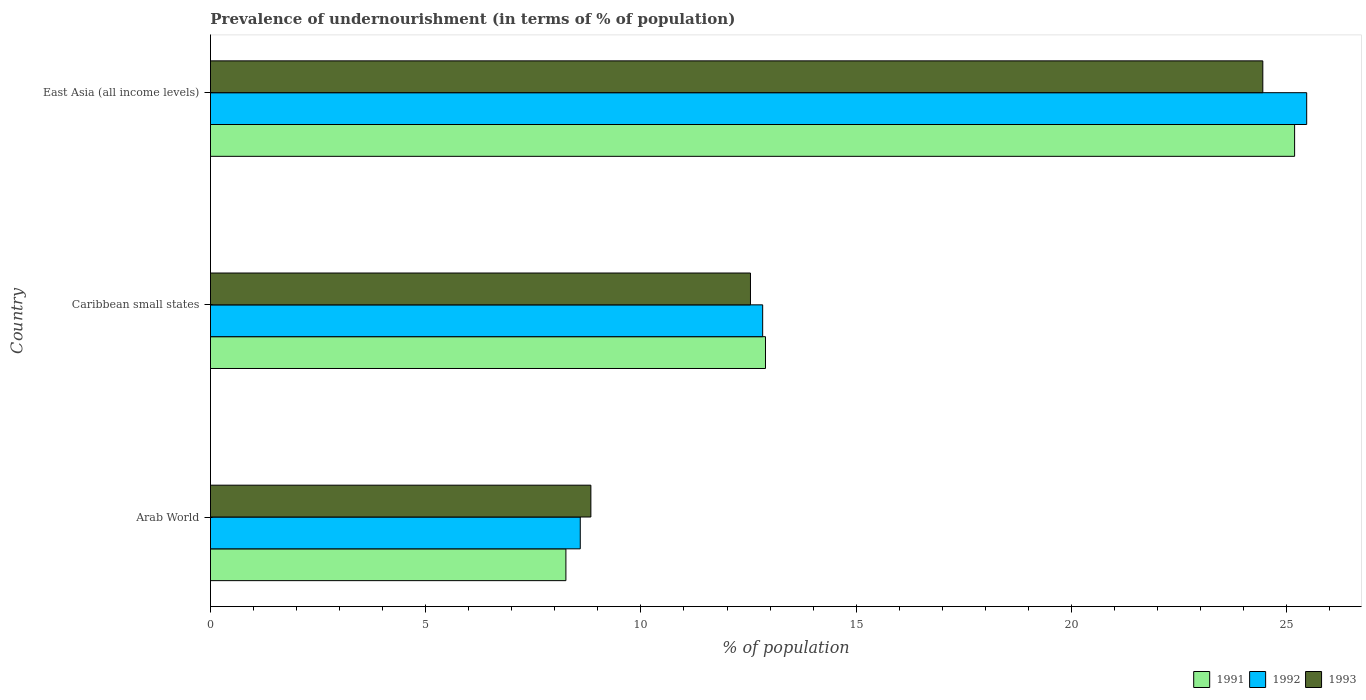How many different coloured bars are there?
Provide a short and direct response. 3. Are the number of bars per tick equal to the number of legend labels?
Make the answer very short. Yes. How many bars are there on the 3rd tick from the top?
Ensure brevity in your answer.  3. What is the label of the 3rd group of bars from the top?
Offer a very short reply. Arab World. In how many cases, is the number of bars for a given country not equal to the number of legend labels?
Make the answer very short. 0. What is the percentage of undernourished population in 1992 in Arab World?
Give a very brief answer. 8.59. Across all countries, what is the maximum percentage of undernourished population in 1993?
Ensure brevity in your answer.  24.45. Across all countries, what is the minimum percentage of undernourished population in 1993?
Offer a terse response. 8.84. In which country was the percentage of undernourished population in 1993 maximum?
Keep it short and to the point. East Asia (all income levels). In which country was the percentage of undernourished population in 1991 minimum?
Offer a very short reply. Arab World. What is the total percentage of undernourished population in 1992 in the graph?
Provide a short and direct response. 46.89. What is the difference between the percentage of undernourished population in 1993 in Caribbean small states and that in East Asia (all income levels)?
Offer a very short reply. -11.9. What is the difference between the percentage of undernourished population in 1992 in Caribbean small states and the percentage of undernourished population in 1993 in East Asia (all income levels)?
Give a very brief answer. -11.62. What is the average percentage of undernourished population in 1991 per country?
Your response must be concise. 15.45. What is the difference between the percentage of undernourished population in 1993 and percentage of undernourished population in 1991 in Arab World?
Make the answer very short. 0.58. What is the ratio of the percentage of undernourished population in 1991 in Caribbean small states to that in East Asia (all income levels)?
Offer a very short reply. 0.51. Is the percentage of undernourished population in 1992 in Arab World less than that in East Asia (all income levels)?
Your response must be concise. Yes. What is the difference between the highest and the second highest percentage of undernourished population in 1993?
Make the answer very short. 11.9. What is the difference between the highest and the lowest percentage of undernourished population in 1991?
Your answer should be compact. 16.93. Is the sum of the percentage of undernourished population in 1992 in Caribbean small states and East Asia (all income levels) greater than the maximum percentage of undernourished population in 1991 across all countries?
Ensure brevity in your answer.  Yes. What does the 1st bar from the top in East Asia (all income levels) represents?
Your answer should be compact. 1993. Is it the case that in every country, the sum of the percentage of undernourished population in 1991 and percentage of undernourished population in 1993 is greater than the percentage of undernourished population in 1992?
Your answer should be compact. Yes. How many bars are there?
Ensure brevity in your answer.  9. Are all the bars in the graph horizontal?
Your answer should be compact. Yes. How many countries are there in the graph?
Your answer should be very brief. 3. Does the graph contain any zero values?
Provide a succinct answer. No. Does the graph contain grids?
Your answer should be very brief. No. Where does the legend appear in the graph?
Keep it short and to the point. Bottom right. How are the legend labels stacked?
Offer a terse response. Horizontal. What is the title of the graph?
Offer a terse response. Prevalence of undernourishment (in terms of % of population). Does "1962" appear as one of the legend labels in the graph?
Give a very brief answer. No. What is the label or title of the X-axis?
Provide a succinct answer. % of population. What is the label or title of the Y-axis?
Your answer should be compact. Country. What is the % of population in 1991 in Arab World?
Give a very brief answer. 8.26. What is the % of population in 1992 in Arab World?
Offer a terse response. 8.59. What is the % of population in 1993 in Arab World?
Offer a terse response. 8.84. What is the % of population of 1991 in Caribbean small states?
Offer a very short reply. 12.89. What is the % of population in 1992 in Caribbean small states?
Keep it short and to the point. 12.83. What is the % of population in 1993 in Caribbean small states?
Ensure brevity in your answer.  12.54. What is the % of population of 1991 in East Asia (all income levels)?
Your answer should be very brief. 25.19. What is the % of population in 1992 in East Asia (all income levels)?
Provide a short and direct response. 25.47. What is the % of population of 1993 in East Asia (all income levels)?
Your response must be concise. 24.45. Across all countries, what is the maximum % of population of 1991?
Give a very brief answer. 25.19. Across all countries, what is the maximum % of population of 1992?
Provide a succinct answer. 25.47. Across all countries, what is the maximum % of population of 1993?
Ensure brevity in your answer.  24.45. Across all countries, what is the minimum % of population in 1991?
Your answer should be very brief. 8.26. Across all countries, what is the minimum % of population of 1992?
Your response must be concise. 8.59. Across all countries, what is the minimum % of population in 1993?
Give a very brief answer. 8.84. What is the total % of population of 1991 in the graph?
Provide a succinct answer. 46.34. What is the total % of population in 1992 in the graph?
Your response must be concise. 46.89. What is the total % of population in 1993 in the graph?
Make the answer very short. 45.83. What is the difference between the % of population of 1991 in Arab World and that in Caribbean small states?
Your answer should be compact. -4.64. What is the difference between the % of population in 1992 in Arab World and that in Caribbean small states?
Keep it short and to the point. -4.24. What is the difference between the % of population of 1993 in Arab World and that in Caribbean small states?
Your response must be concise. -3.71. What is the difference between the % of population in 1991 in Arab World and that in East Asia (all income levels)?
Give a very brief answer. -16.93. What is the difference between the % of population in 1992 in Arab World and that in East Asia (all income levels)?
Ensure brevity in your answer.  -16.88. What is the difference between the % of population in 1993 in Arab World and that in East Asia (all income levels)?
Your response must be concise. -15.61. What is the difference between the % of population of 1991 in Caribbean small states and that in East Asia (all income levels)?
Make the answer very short. -12.29. What is the difference between the % of population in 1992 in Caribbean small states and that in East Asia (all income levels)?
Provide a short and direct response. -12.64. What is the difference between the % of population of 1993 in Caribbean small states and that in East Asia (all income levels)?
Offer a terse response. -11.9. What is the difference between the % of population of 1991 in Arab World and the % of population of 1992 in Caribbean small states?
Ensure brevity in your answer.  -4.57. What is the difference between the % of population of 1991 in Arab World and the % of population of 1993 in Caribbean small states?
Your answer should be very brief. -4.29. What is the difference between the % of population in 1992 in Arab World and the % of population in 1993 in Caribbean small states?
Ensure brevity in your answer.  -3.95. What is the difference between the % of population in 1991 in Arab World and the % of population in 1992 in East Asia (all income levels)?
Give a very brief answer. -17.21. What is the difference between the % of population of 1991 in Arab World and the % of population of 1993 in East Asia (all income levels)?
Ensure brevity in your answer.  -16.19. What is the difference between the % of population of 1992 in Arab World and the % of population of 1993 in East Asia (all income levels)?
Offer a very short reply. -15.86. What is the difference between the % of population of 1991 in Caribbean small states and the % of population of 1992 in East Asia (all income levels)?
Provide a succinct answer. -12.57. What is the difference between the % of population in 1991 in Caribbean small states and the % of population in 1993 in East Asia (all income levels)?
Provide a short and direct response. -11.55. What is the difference between the % of population of 1992 in Caribbean small states and the % of population of 1993 in East Asia (all income levels)?
Ensure brevity in your answer.  -11.62. What is the average % of population of 1991 per country?
Offer a very short reply. 15.45. What is the average % of population in 1992 per country?
Offer a terse response. 15.63. What is the average % of population of 1993 per country?
Your answer should be very brief. 15.28. What is the difference between the % of population of 1991 and % of population of 1992 in Arab World?
Ensure brevity in your answer.  -0.33. What is the difference between the % of population of 1991 and % of population of 1993 in Arab World?
Give a very brief answer. -0.58. What is the difference between the % of population of 1992 and % of population of 1993 in Arab World?
Your answer should be very brief. -0.25. What is the difference between the % of population of 1991 and % of population of 1992 in Caribbean small states?
Your answer should be very brief. 0.07. What is the difference between the % of population in 1991 and % of population in 1993 in Caribbean small states?
Make the answer very short. 0.35. What is the difference between the % of population of 1992 and % of population of 1993 in Caribbean small states?
Your response must be concise. 0.28. What is the difference between the % of population of 1991 and % of population of 1992 in East Asia (all income levels)?
Ensure brevity in your answer.  -0.28. What is the difference between the % of population in 1991 and % of population in 1993 in East Asia (all income levels)?
Provide a short and direct response. 0.74. What is the ratio of the % of population in 1991 in Arab World to that in Caribbean small states?
Your answer should be compact. 0.64. What is the ratio of the % of population of 1992 in Arab World to that in Caribbean small states?
Your answer should be very brief. 0.67. What is the ratio of the % of population in 1993 in Arab World to that in Caribbean small states?
Your answer should be very brief. 0.7. What is the ratio of the % of population in 1991 in Arab World to that in East Asia (all income levels)?
Provide a succinct answer. 0.33. What is the ratio of the % of population in 1992 in Arab World to that in East Asia (all income levels)?
Your response must be concise. 0.34. What is the ratio of the % of population in 1993 in Arab World to that in East Asia (all income levels)?
Your response must be concise. 0.36. What is the ratio of the % of population in 1991 in Caribbean small states to that in East Asia (all income levels)?
Provide a succinct answer. 0.51. What is the ratio of the % of population in 1992 in Caribbean small states to that in East Asia (all income levels)?
Make the answer very short. 0.5. What is the ratio of the % of population in 1993 in Caribbean small states to that in East Asia (all income levels)?
Offer a very short reply. 0.51. What is the difference between the highest and the second highest % of population in 1991?
Your answer should be compact. 12.29. What is the difference between the highest and the second highest % of population in 1992?
Your answer should be very brief. 12.64. What is the difference between the highest and the second highest % of population of 1993?
Keep it short and to the point. 11.9. What is the difference between the highest and the lowest % of population in 1991?
Your response must be concise. 16.93. What is the difference between the highest and the lowest % of population of 1992?
Offer a very short reply. 16.88. What is the difference between the highest and the lowest % of population of 1993?
Your response must be concise. 15.61. 